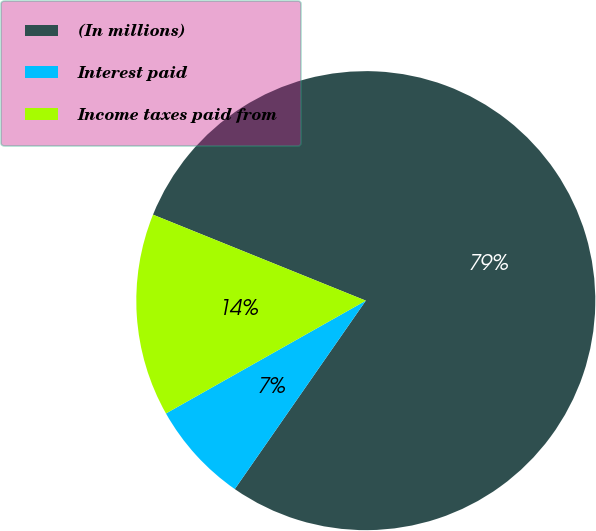<chart> <loc_0><loc_0><loc_500><loc_500><pie_chart><fcel>(In millions)<fcel>Interest paid<fcel>Income taxes paid from<nl><fcel>78.56%<fcel>7.15%<fcel>14.29%<nl></chart> 